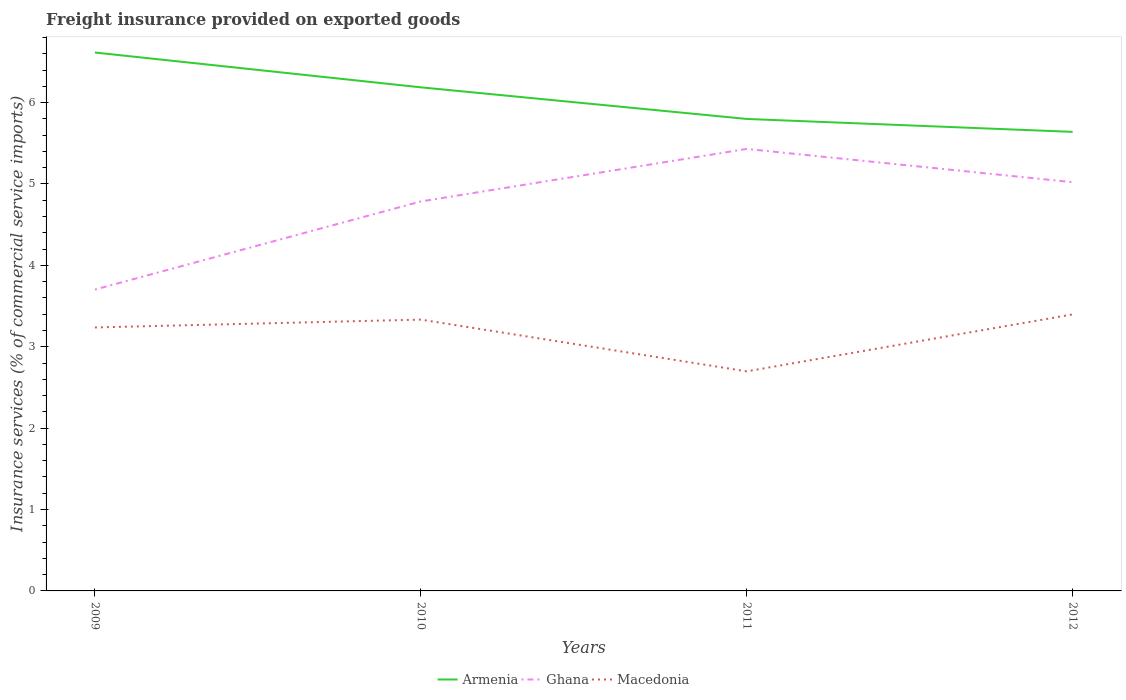Does the line corresponding to Armenia intersect with the line corresponding to Macedonia?
Your answer should be very brief. No. Across all years, what is the maximum freight insurance provided on exported goods in Ghana?
Provide a short and direct response. 3.7. What is the total freight insurance provided on exported goods in Macedonia in the graph?
Give a very brief answer. -0.16. What is the difference between the highest and the second highest freight insurance provided on exported goods in Ghana?
Provide a succinct answer. 1.73. What is the difference between the highest and the lowest freight insurance provided on exported goods in Ghana?
Your answer should be very brief. 3. Is the freight insurance provided on exported goods in Armenia strictly greater than the freight insurance provided on exported goods in Ghana over the years?
Offer a very short reply. No. How many lines are there?
Keep it short and to the point. 3. How many years are there in the graph?
Keep it short and to the point. 4. Does the graph contain any zero values?
Provide a short and direct response. No. Does the graph contain grids?
Offer a very short reply. No. How are the legend labels stacked?
Provide a succinct answer. Horizontal. What is the title of the graph?
Your answer should be very brief. Freight insurance provided on exported goods. What is the label or title of the Y-axis?
Ensure brevity in your answer.  Insurance services (% of commercial service imports). What is the Insurance services (% of commercial service imports) in Armenia in 2009?
Ensure brevity in your answer.  6.62. What is the Insurance services (% of commercial service imports) in Ghana in 2009?
Offer a very short reply. 3.7. What is the Insurance services (% of commercial service imports) of Macedonia in 2009?
Make the answer very short. 3.24. What is the Insurance services (% of commercial service imports) in Armenia in 2010?
Provide a short and direct response. 6.19. What is the Insurance services (% of commercial service imports) in Ghana in 2010?
Keep it short and to the point. 4.79. What is the Insurance services (% of commercial service imports) of Macedonia in 2010?
Give a very brief answer. 3.33. What is the Insurance services (% of commercial service imports) of Armenia in 2011?
Make the answer very short. 5.8. What is the Insurance services (% of commercial service imports) in Ghana in 2011?
Offer a terse response. 5.43. What is the Insurance services (% of commercial service imports) of Macedonia in 2011?
Your answer should be very brief. 2.7. What is the Insurance services (% of commercial service imports) of Armenia in 2012?
Provide a succinct answer. 5.64. What is the Insurance services (% of commercial service imports) of Ghana in 2012?
Your response must be concise. 5.02. What is the Insurance services (% of commercial service imports) of Macedonia in 2012?
Offer a terse response. 3.4. Across all years, what is the maximum Insurance services (% of commercial service imports) in Armenia?
Provide a succinct answer. 6.62. Across all years, what is the maximum Insurance services (% of commercial service imports) of Ghana?
Your response must be concise. 5.43. Across all years, what is the maximum Insurance services (% of commercial service imports) in Macedonia?
Offer a terse response. 3.4. Across all years, what is the minimum Insurance services (% of commercial service imports) in Armenia?
Keep it short and to the point. 5.64. Across all years, what is the minimum Insurance services (% of commercial service imports) of Ghana?
Provide a short and direct response. 3.7. Across all years, what is the minimum Insurance services (% of commercial service imports) in Macedonia?
Offer a terse response. 2.7. What is the total Insurance services (% of commercial service imports) in Armenia in the graph?
Provide a short and direct response. 24.24. What is the total Insurance services (% of commercial service imports) of Ghana in the graph?
Make the answer very short. 18.94. What is the total Insurance services (% of commercial service imports) in Macedonia in the graph?
Provide a short and direct response. 12.67. What is the difference between the Insurance services (% of commercial service imports) in Armenia in 2009 and that in 2010?
Your answer should be very brief. 0.43. What is the difference between the Insurance services (% of commercial service imports) of Ghana in 2009 and that in 2010?
Offer a very short reply. -1.08. What is the difference between the Insurance services (% of commercial service imports) in Macedonia in 2009 and that in 2010?
Your answer should be very brief. -0.1. What is the difference between the Insurance services (% of commercial service imports) in Armenia in 2009 and that in 2011?
Provide a succinct answer. 0.82. What is the difference between the Insurance services (% of commercial service imports) in Ghana in 2009 and that in 2011?
Offer a terse response. -1.73. What is the difference between the Insurance services (% of commercial service imports) in Macedonia in 2009 and that in 2011?
Offer a terse response. 0.54. What is the difference between the Insurance services (% of commercial service imports) in Armenia in 2009 and that in 2012?
Offer a terse response. 0.97. What is the difference between the Insurance services (% of commercial service imports) in Ghana in 2009 and that in 2012?
Provide a succinct answer. -1.32. What is the difference between the Insurance services (% of commercial service imports) of Macedonia in 2009 and that in 2012?
Provide a succinct answer. -0.16. What is the difference between the Insurance services (% of commercial service imports) of Armenia in 2010 and that in 2011?
Keep it short and to the point. 0.39. What is the difference between the Insurance services (% of commercial service imports) of Ghana in 2010 and that in 2011?
Keep it short and to the point. -0.65. What is the difference between the Insurance services (% of commercial service imports) in Macedonia in 2010 and that in 2011?
Provide a short and direct response. 0.64. What is the difference between the Insurance services (% of commercial service imports) in Armenia in 2010 and that in 2012?
Your answer should be compact. 0.55. What is the difference between the Insurance services (% of commercial service imports) of Ghana in 2010 and that in 2012?
Your answer should be very brief. -0.24. What is the difference between the Insurance services (% of commercial service imports) in Macedonia in 2010 and that in 2012?
Your answer should be compact. -0.06. What is the difference between the Insurance services (% of commercial service imports) of Armenia in 2011 and that in 2012?
Offer a very short reply. 0.16. What is the difference between the Insurance services (% of commercial service imports) in Ghana in 2011 and that in 2012?
Ensure brevity in your answer.  0.41. What is the difference between the Insurance services (% of commercial service imports) of Macedonia in 2011 and that in 2012?
Provide a succinct answer. -0.7. What is the difference between the Insurance services (% of commercial service imports) in Armenia in 2009 and the Insurance services (% of commercial service imports) in Ghana in 2010?
Provide a short and direct response. 1.83. What is the difference between the Insurance services (% of commercial service imports) in Armenia in 2009 and the Insurance services (% of commercial service imports) in Macedonia in 2010?
Provide a short and direct response. 3.28. What is the difference between the Insurance services (% of commercial service imports) of Ghana in 2009 and the Insurance services (% of commercial service imports) of Macedonia in 2010?
Your answer should be compact. 0.37. What is the difference between the Insurance services (% of commercial service imports) of Armenia in 2009 and the Insurance services (% of commercial service imports) of Ghana in 2011?
Ensure brevity in your answer.  1.18. What is the difference between the Insurance services (% of commercial service imports) of Armenia in 2009 and the Insurance services (% of commercial service imports) of Macedonia in 2011?
Give a very brief answer. 3.92. What is the difference between the Insurance services (% of commercial service imports) in Ghana in 2009 and the Insurance services (% of commercial service imports) in Macedonia in 2011?
Make the answer very short. 1. What is the difference between the Insurance services (% of commercial service imports) in Armenia in 2009 and the Insurance services (% of commercial service imports) in Ghana in 2012?
Keep it short and to the point. 1.59. What is the difference between the Insurance services (% of commercial service imports) of Armenia in 2009 and the Insurance services (% of commercial service imports) of Macedonia in 2012?
Your answer should be very brief. 3.22. What is the difference between the Insurance services (% of commercial service imports) in Ghana in 2009 and the Insurance services (% of commercial service imports) in Macedonia in 2012?
Provide a short and direct response. 0.31. What is the difference between the Insurance services (% of commercial service imports) of Armenia in 2010 and the Insurance services (% of commercial service imports) of Ghana in 2011?
Provide a succinct answer. 0.76. What is the difference between the Insurance services (% of commercial service imports) in Armenia in 2010 and the Insurance services (% of commercial service imports) in Macedonia in 2011?
Ensure brevity in your answer.  3.49. What is the difference between the Insurance services (% of commercial service imports) of Ghana in 2010 and the Insurance services (% of commercial service imports) of Macedonia in 2011?
Offer a terse response. 2.09. What is the difference between the Insurance services (% of commercial service imports) of Armenia in 2010 and the Insurance services (% of commercial service imports) of Ghana in 2012?
Your response must be concise. 1.17. What is the difference between the Insurance services (% of commercial service imports) in Armenia in 2010 and the Insurance services (% of commercial service imports) in Macedonia in 2012?
Provide a succinct answer. 2.79. What is the difference between the Insurance services (% of commercial service imports) in Ghana in 2010 and the Insurance services (% of commercial service imports) in Macedonia in 2012?
Ensure brevity in your answer.  1.39. What is the difference between the Insurance services (% of commercial service imports) in Armenia in 2011 and the Insurance services (% of commercial service imports) in Ghana in 2012?
Ensure brevity in your answer.  0.78. What is the difference between the Insurance services (% of commercial service imports) in Armenia in 2011 and the Insurance services (% of commercial service imports) in Macedonia in 2012?
Your answer should be compact. 2.4. What is the difference between the Insurance services (% of commercial service imports) of Ghana in 2011 and the Insurance services (% of commercial service imports) of Macedonia in 2012?
Provide a succinct answer. 2.03. What is the average Insurance services (% of commercial service imports) of Armenia per year?
Make the answer very short. 6.06. What is the average Insurance services (% of commercial service imports) in Ghana per year?
Your answer should be compact. 4.74. What is the average Insurance services (% of commercial service imports) of Macedonia per year?
Provide a short and direct response. 3.17. In the year 2009, what is the difference between the Insurance services (% of commercial service imports) in Armenia and Insurance services (% of commercial service imports) in Ghana?
Your answer should be very brief. 2.91. In the year 2009, what is the difference between the Insurance services (% of commercial service imports) of Armenia and Insurance services (% of commercial service imports) of Macedonia?
Offer a terse response. 3.38. In the year 2009, what is the difference between the Insurance services (% of commercial service imports) in Ghana and Insurance services (% of commercial service imports) in Macedonia?
Provide a short and direct response. 0.47. In the year 2010, what is the difference between the Insurance services (% of commercial service imports) of Armenia and Insurance services (% of commercial service imports) of Ghana?
Keep it short and to the point. 1.4. In the year 2010, what is the difference between the Insurance services (% of commercial service imports) of Armenia and Insurance services (% of commercial service imports) of Macedonia?
Provide a succinct answer. 2.85. In the year 2010, what is the difference between the Insurance services (% of commercial service imports) of Ghana and Insurance services (% of commercial service imports) of Macedonia?
Keep it short and to the point. 1.45. In the year 2011, what is the difference between the Insurance services (% of commercial service imports) of Armenia and Insurance services (% of commercial service imports) of Ghana?
Offer a terse response. 0.37. In the year 2011, what is the difference between the Insurance services (% of commercial service imports) of Armenia and Insurance services (% of commercial service imports) of Macedonia?
Give a very brief answer. 3.1. In the year 2011, what is the difference between the Insurance services (% of commercial service imports) in Ghana and Insurance services (% of commercial service imports) in Macedonia?
Offer a terse response. 2.73. In the year 2012, what is the difference between the Insurance services (% of commercial service imports) of Armenia and Insurance services (% of commercial service imports) of Ghana?
Ensure brevity in your answer.  0.62. In the year 2012, what is the difference between the Insurance services (% of commercial service imports) in Armenia and Insurance services (% of commercial service imports) in Macedonia?
Your answer should be compact. 2.24. In the year 2012, what is the difference between the Insurance services (% of commercial service imports) in Ghana and Insurance services (% of commercial service imports) in Macedonia?
Make the answer very short. 1.62. What is the ratio of the Insurance services (% of commercial service imports) of Armenia in 2009 to that in 2010?
Provide a short and direct response. 1.07. What is the ratio of the Insurance services (% of commercial service imports) of Ghana in 2009 to that in 2010?
Your response must be concise. 0.77. What is the ratio of the Insurance services (% of commercial service imports) of Macedonia in 2009 to that in 2010?
Your response must be concise. 0.97. What is the ratio of the Insurance services (% of commercial service imports) in Armenia in 2009 to that in 2011?
Offer a very short reply. 1.14. What is the ratio of the Insurance services (% of commercial service imports) of Ghana in 2009 to that in 2011?
Your answer should be compact. 0.68. What is the ratio of the Insurance services (% of commercial service imports) of Macedonia in 2009 to that in 2011?
Give a very brief answer. 1.2. What is the ratio of the Insurance services (% of commercial service imports) in Armenia in 2009 to that in 2012?
Provide a short and direct response. 1.17. What is the ratio of the Insurance services (% of commercial service imports) of Ghana in 2009 to that in 2012?
Provide a short and direct response. 0.74. What is the ratio of the Insurance services (% of commercial service imports) of Macedonia in 2009 to that in 2012?
Provide a succinct answer. 0.95. What is the ratio of the Insurance services (% of commercial service imports) of Armenia in 2010 to that in 2011?
Your response must be concise. 1.07. What is the ratio of the Insurance services (% of commercial service imports) in Ghana in 2010 to that in 2011?
Make the answer very short. 0.88. What is the ratio of the Insurance services (% of commercial service imports) in Macedonia in 2010 to that in 2011?
Make the answer very short. 1.24. What is the ratio of the Insurance services (% of commercial service imports) of Armenia in 2010 to that in 2012?
Your answer should be compact. 1.1. What is the ratio of the Insurance services (% of commercial service imports) in Ghana in 2010 to that in 2012?
Offer a very short reply. 0.95. What is the ratio of the Insurance services (% of commercial service imports) of Macedonia in 2010 to that in 2012?
Ensure brevity in your answer.  0.98. What is the ratio of the Insurance services (% of commercial service imports) in Armenia in 2011 to that in 2012?
Offer a very short reply. 1.03. What is the ratio of the Insurance services (% of commercial service imports) in Ghana in 2011 to that in 2012?
Make the answer very short. 1.08. What is the ratio of the Insurance services (% of commercial service imports) of Macedonia in 2011 to that in 2012?
Ensure brevity in your answer.  0.79. What is the difference between the highest and the second highest Insurance services (% of commercial service imports) in Armenia?
Your answer should be very brief. 0.43. What is the difference between the highest and the second highest Insurance services (% of commercial service imports) of Ghana?
Keep it short and to the point. 0.41. What is the difference between the highest and the second highest Insurance services (% of commercial service imports) of Macedonia?
Make the answer very short. 0.06. What is the difference between the highest and the lowest Insurance services (% of commercial service imports) in Armenia?
Give a very brief answer. 0.97. What is the difference between the highest and the lowest Insurance services (% of commercial service imports) of Ghana?
Keep it short and to the point. 1.73. What is the difference between the highest and the lowest Insurance services (% of commercial service imports) in Macedonia?
Keep it short and to the point. 0.7. 